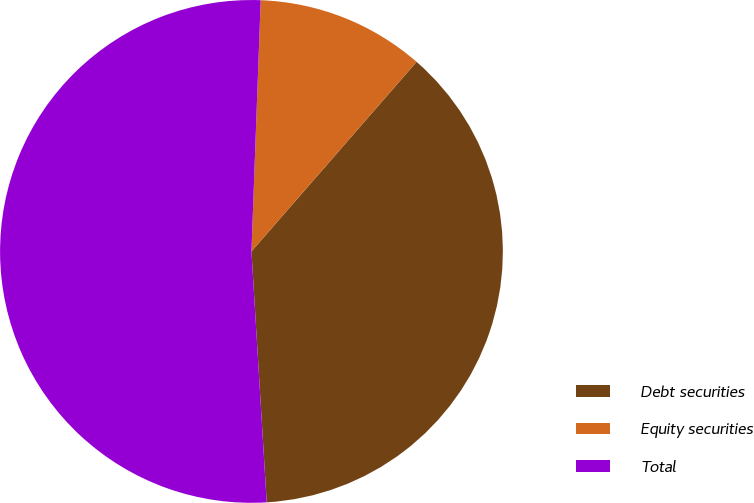Convert chart. <chart><loc_0><loc_0><loc_500><loc_500><pie_chart><fcel>Debt securities<fcel>Equity securities<fcel>Total<nl><fcel>37.63%<fcel>10.82%<fcel>51.55%<nl></chart> 